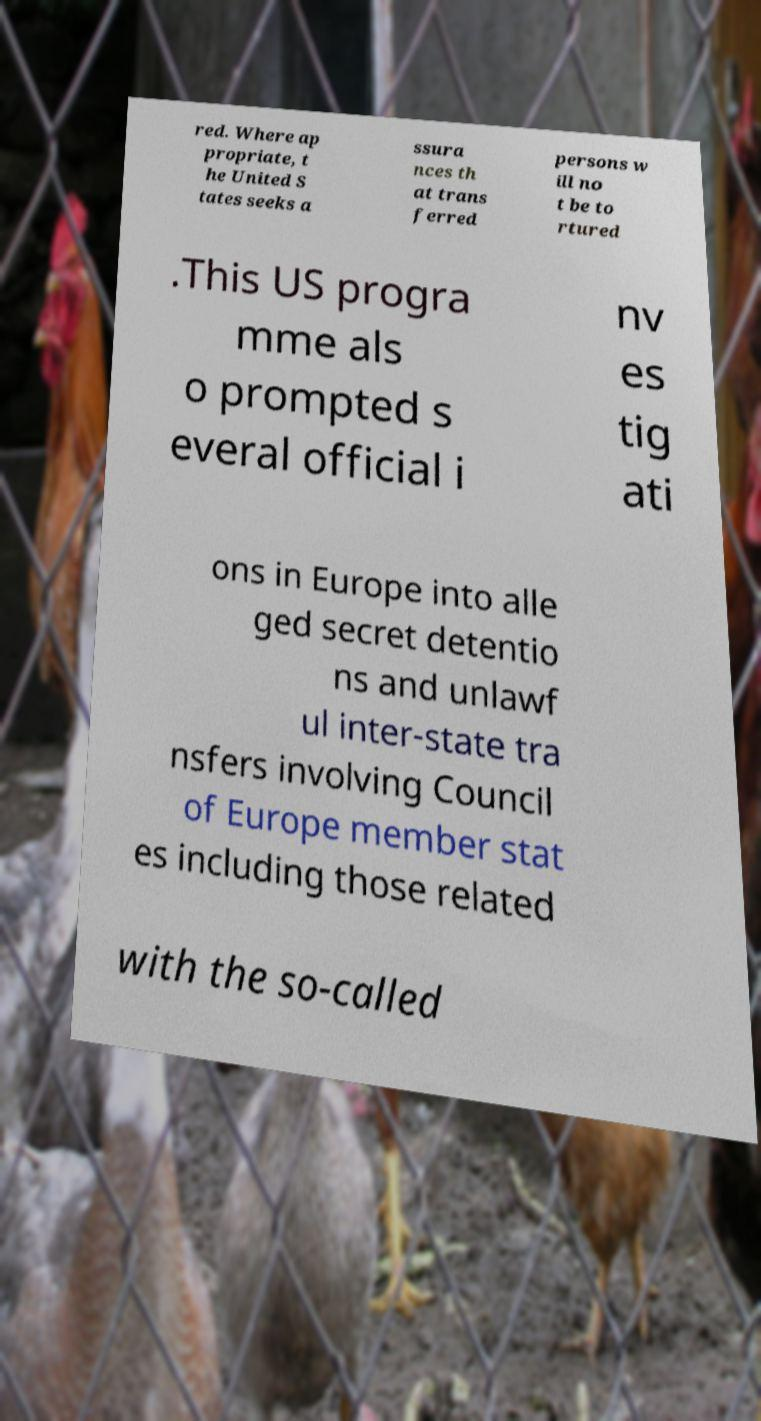Can you accurately transcribe the text from the provided image for me? red. Where ap propriate, t he United S tates seeks a ssura nces th at trans ferred persons w ill no t be to rtured .This US progra mme als o prompted s everal official i nv es tig ati ons in Europe into alle ged secret detentio ns and unlawf ul inter-state tra nsfers involving Council of Europe member stat es including those related with the so-called 